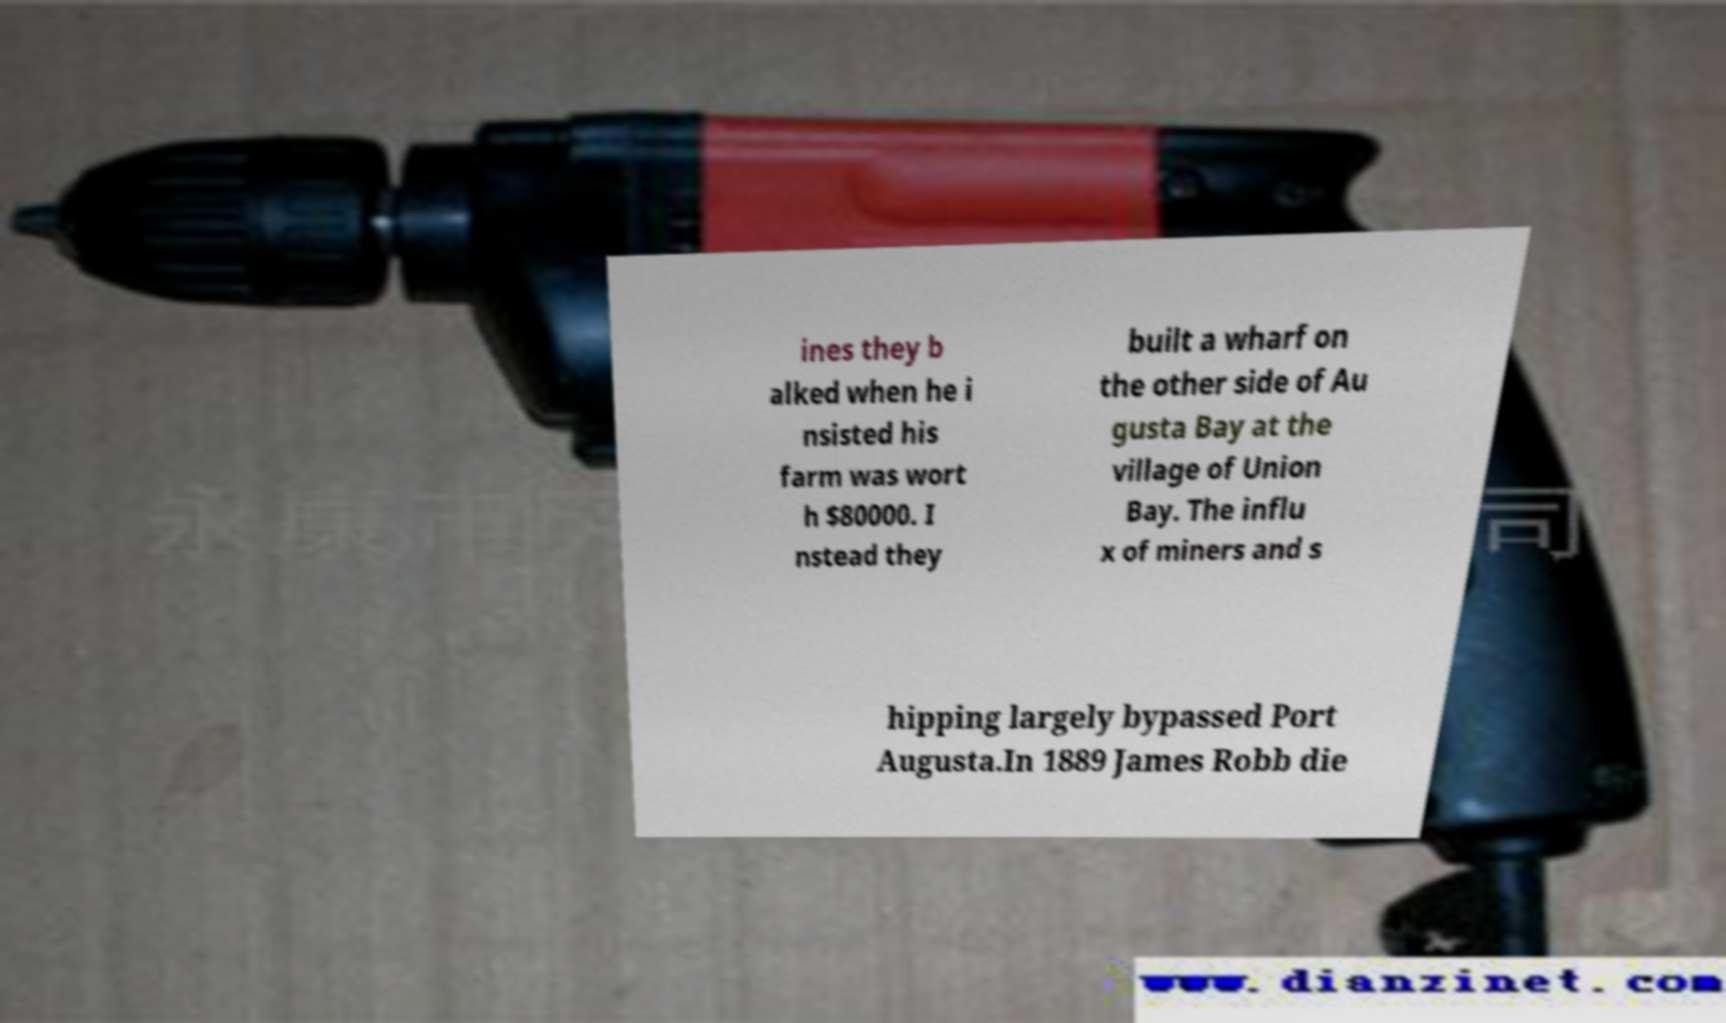Can you read and provide the text displayed in the image?This photo seems to have some interesting text. Can you extract and type it out for me? ines they b alked when he i nsisted his farm was wort h $80000. I nstead they built a wharf on the other side of Au gusta Bay at the village of Union Bay. The influ x of miners and s hipping largely bypassed Port Augusta.In 1889 James Robb die 